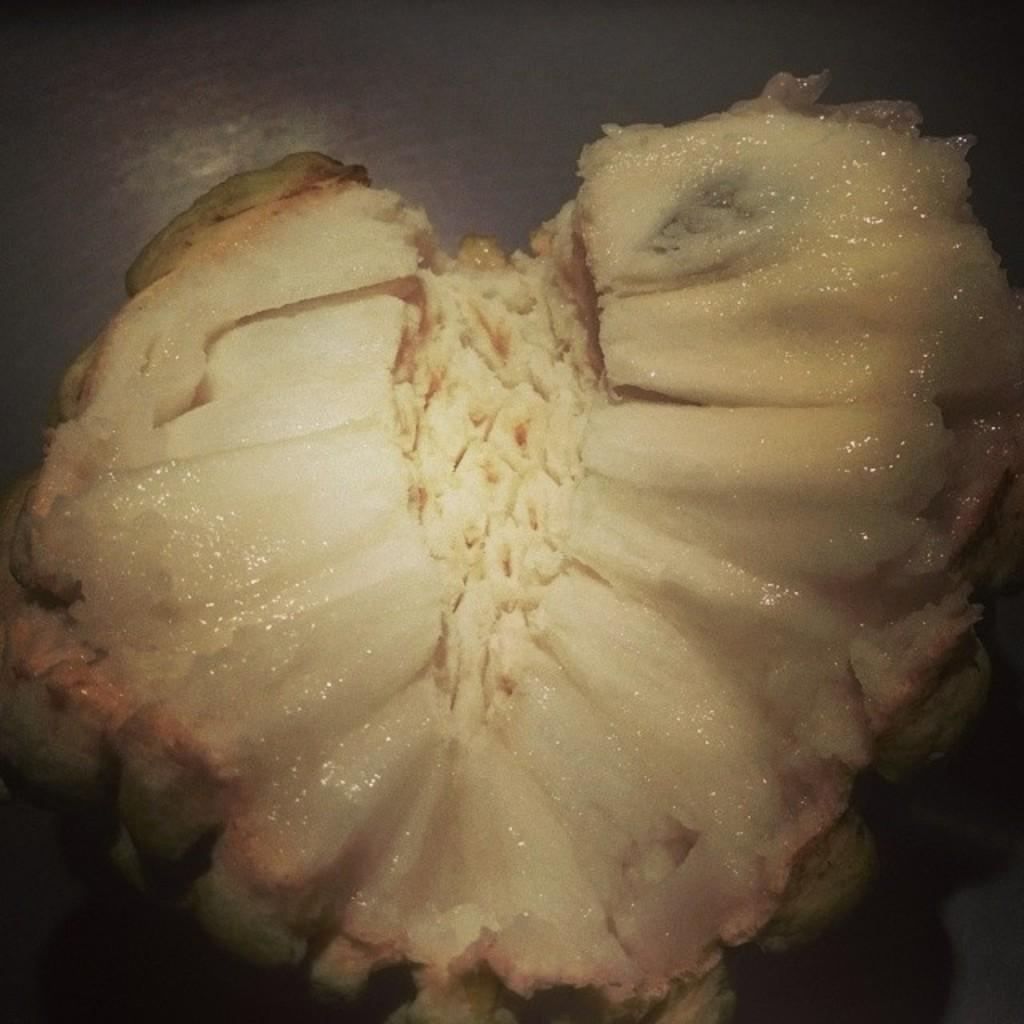What type of fruit is in the image? There is a piece of custard apple in the image. What colors can be seen on the custard apple? The custard apple has a white and green color. What is the number of beliefs held by the custard apple in the image? Custard apples do not hold beliefs, as they are fruits and not living beings capable of holding beliefs. 